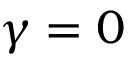Convert formula to latex. <formula><loc_0><loc_0><loc_500><loc_500>\gamma = 0</formula> 